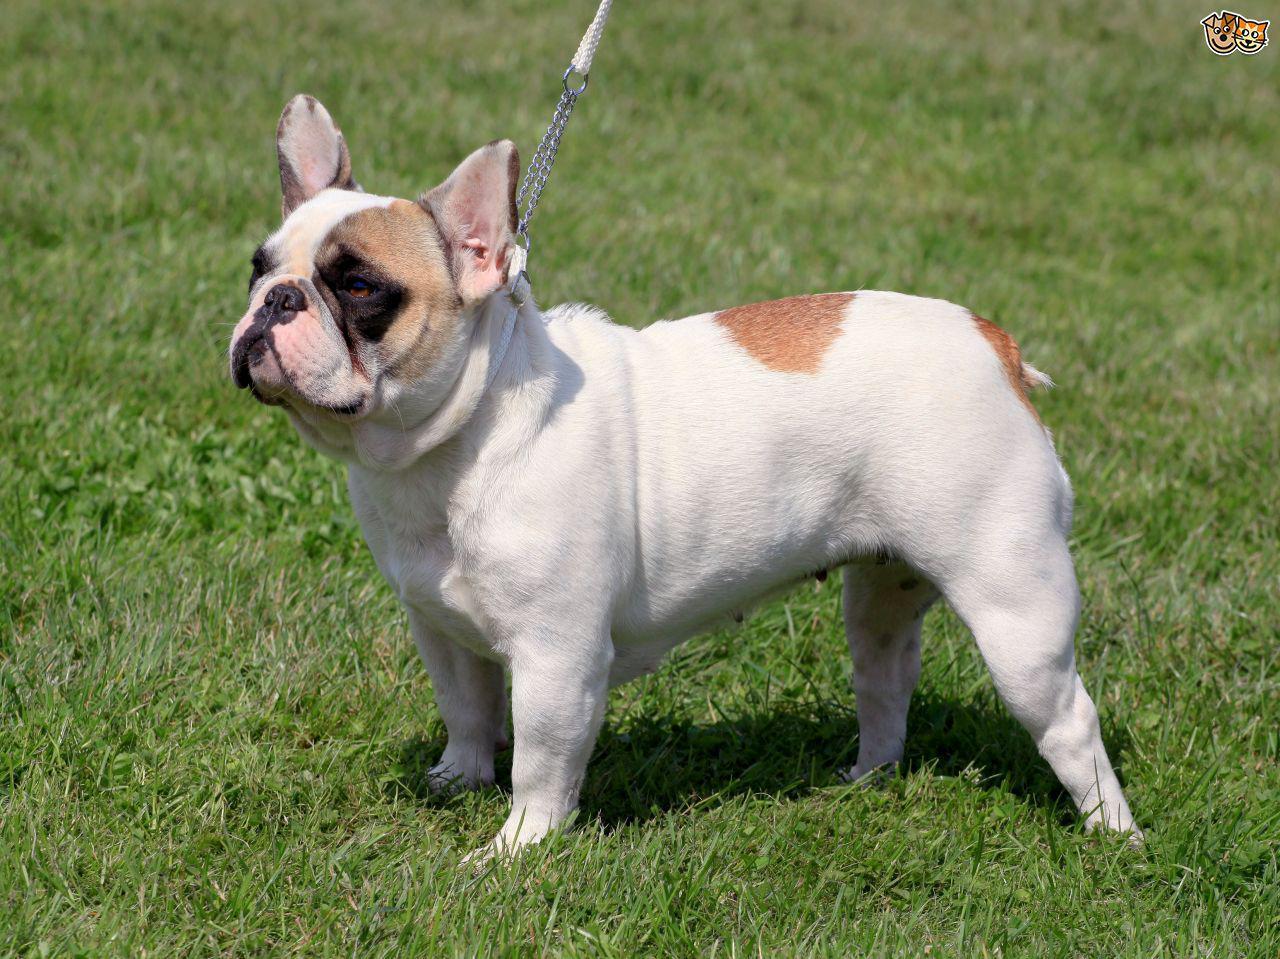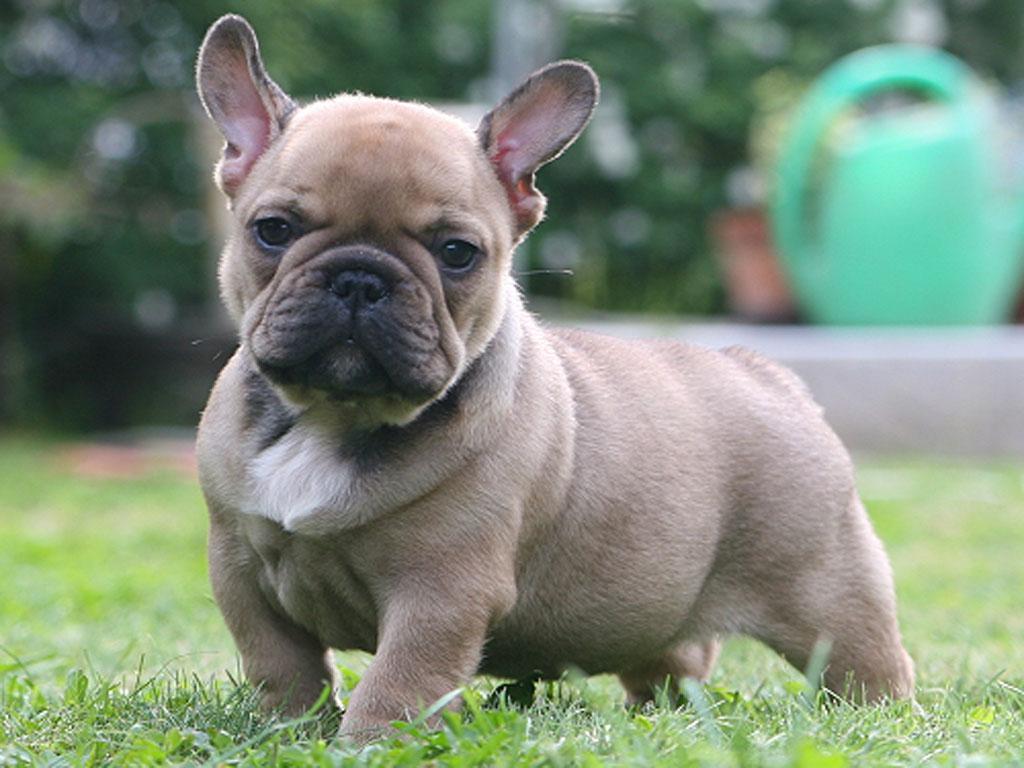The first image is the image on the left, the second image is the image on the right. Given the left and right images, does the statement "One of the images does not show the entire body of the dog." hold true? Answer yes or no. No. 